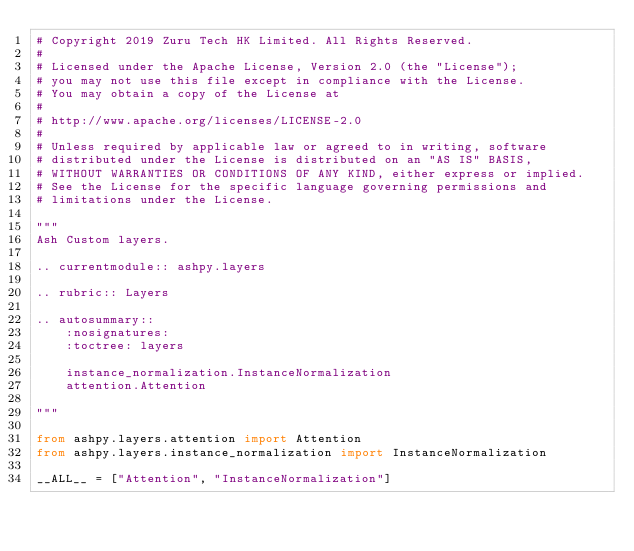<code> <loc_0><loc_0><loc_500><loc_500><_Python_># Copyright 2019 Zuru Tech HK Limited. All Rights Reserved.
#
# Licensed under the Apache License, Version 2.0 (the "License");
# you may not use this file except in compliance with the License.
# You may obtain a copy of the License at
#
# http://www.apache.org/licenses/LICENSE-2.0
#
# Unless required by applicable law or agreed to in writing, software
# distributed under the License is distributed on an "AS IS" BASIS,
# WITHOUT WARRANTIES OR CONDITIONS OF ANY KIND, either express or implied.
# See the License for the specific language governing permissions and
# limitations under the License.

"""
Ash Custom layers.

.. currentmodule:: ashpy.layers

.. rubric:: Layers

.. autosummary::
    :nosignatures:
    :toctree: layers

    instance_normalization.InstanceNormalization
    attention.Attention

"""

from ashpy.layers.attention import Attention
from ashpy.layers.instance_normalization import InstanceNormalization

__ALL__ = ["Attention", "InstanceNormalization"]
</code> 